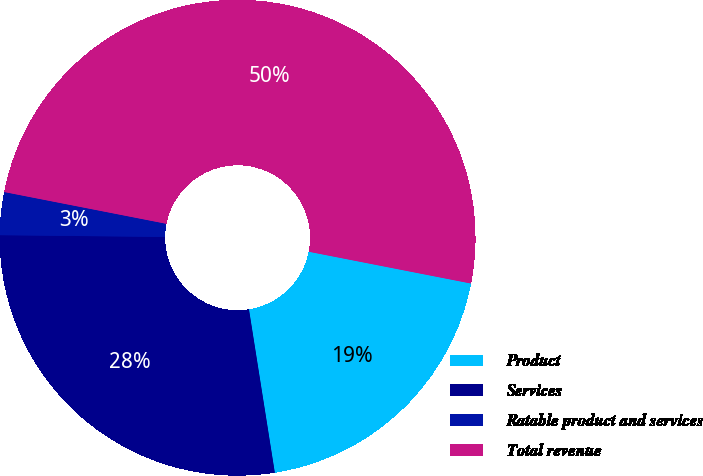<chart> <loc_0><loc_0><loc_500><loc_500><pie_chart><fcel>Product<fcel>Services<fcel>Ratable product and services<fcel>Total revenue<nl><fcel>19.42%<fcel>27.67%<fcel>2.91%<fcel>50.0%<nl></chart> 